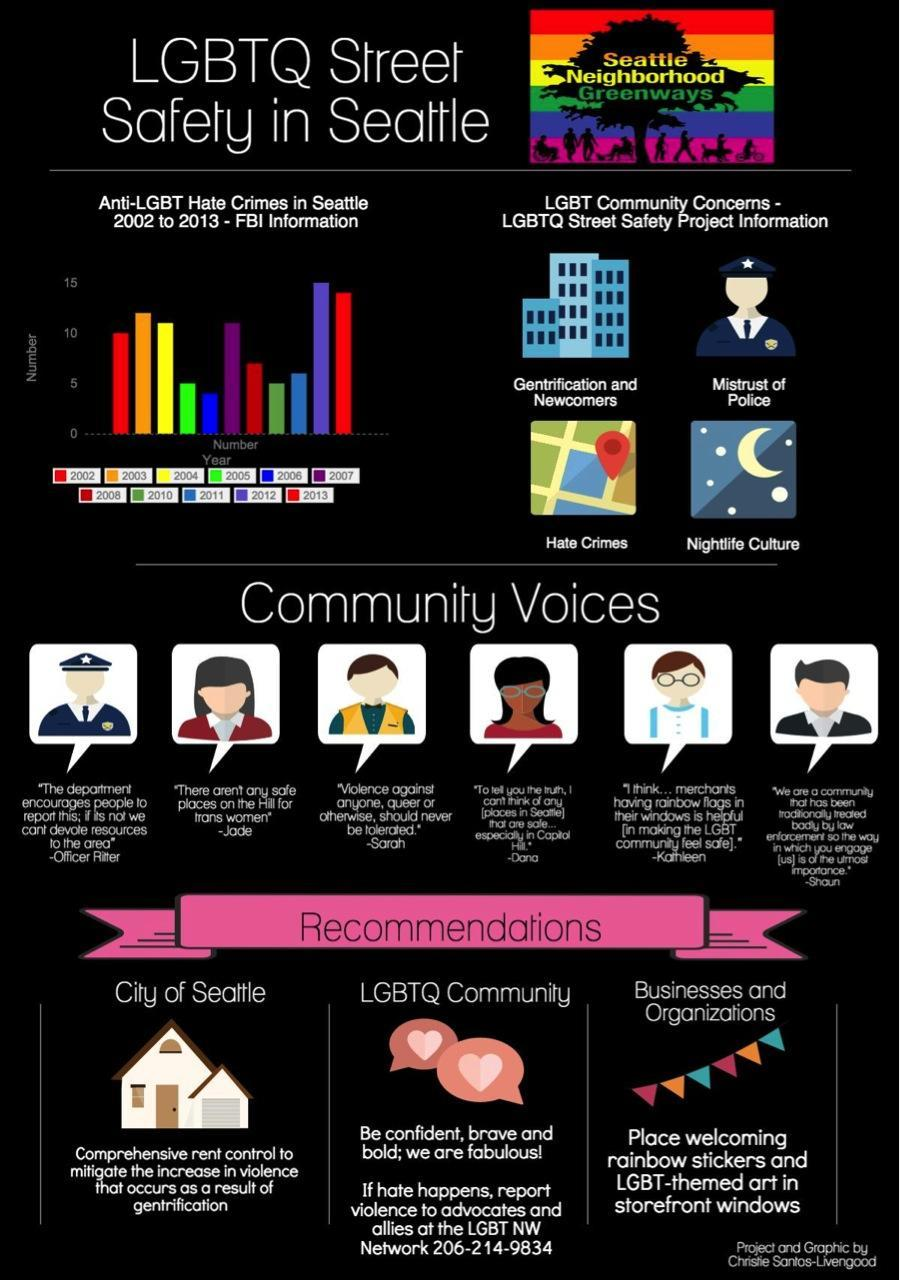Which year has the Anti-LGBT Hate Crime in Seattle been the second lowest
Answer the question with a short phrase. 2005 how many recommendations have been mentioned 3 